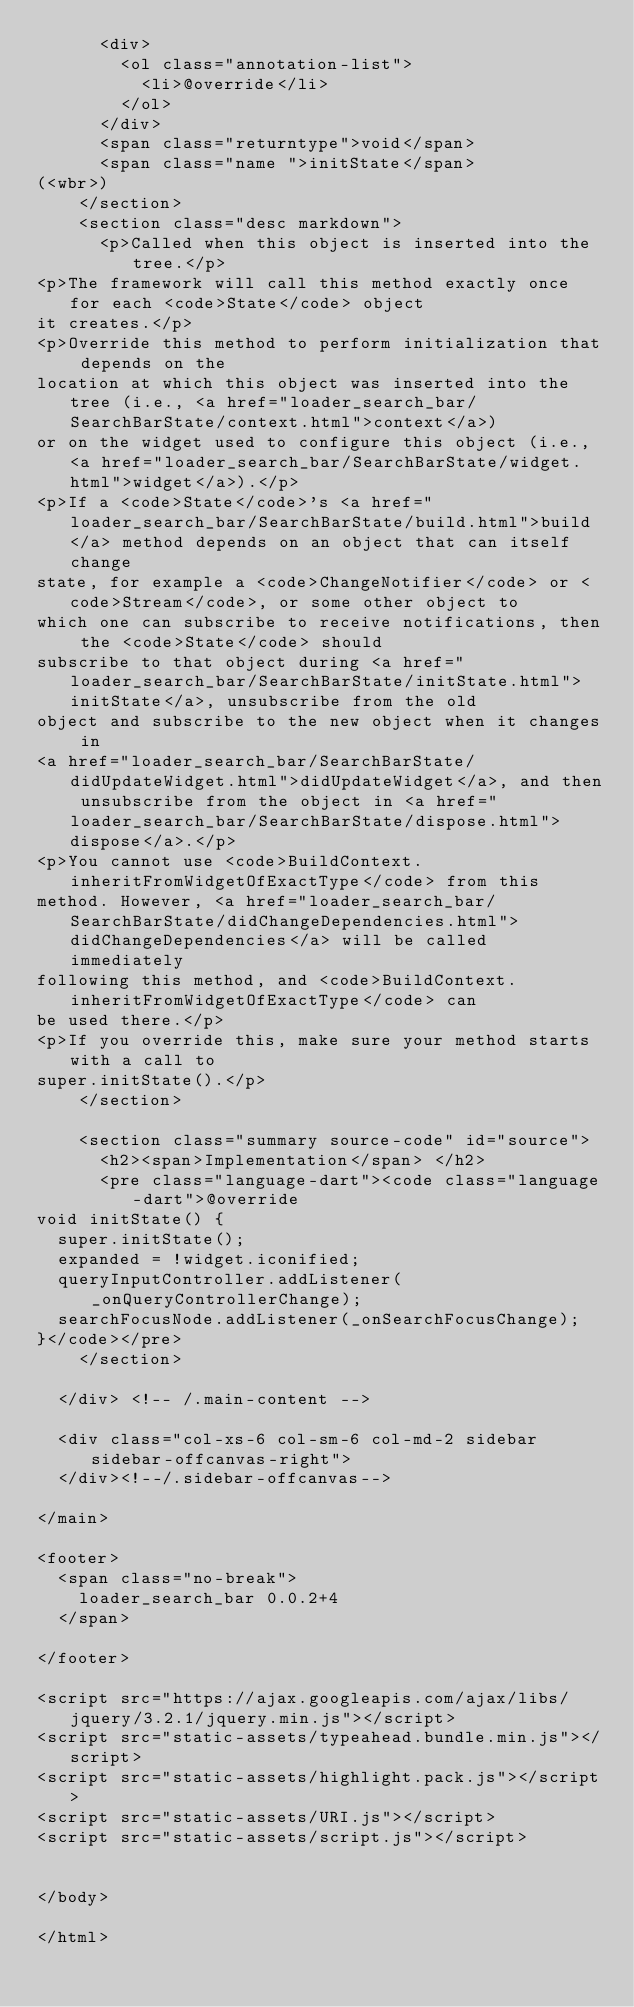<code> <loc_0><loc_0><loc_500><loc_500><_HTML_>      <div>
        <ol class="annotation-list">
          <li>@override</li>
        </ol>
      </div>
      <span class="returntype">void</span>
      <span class="name ">initState</span>
(<wbr>)
    </section>
    <section class="desc markdown">
      <p>Called when this object is inserted into the tree.</p>
<p>The framework will call this method exactly once for each <code>State</code> object
it creates.</p>
<p>Override this method to perform initialization that depends on the
location at which this object was inserted into the tree (i.e., <a href="loader_search_bar/SearchBarState/context.html">context</a>)
or on the widget used to configure this object (i.e., <a href="loader_search_bar/SearchBarState/widget.html">widget</a>).</p>
<p>If a <code>State</code>'s <a href="loader_search_bar/SearchBarState/build.html">build</a> method depends on an object that can itself change
state, for example a <code>ChangeNotifier</code> or <code>Stream</code>, or some other object to
which one can subscribe to receive notifications, then the <code>State</code> should
subscribe to that object during <a href="loader_search_bar/SearchBarState/initState.html">initState</a>, unsubscribe from the old
object and subscribe to the new object when it changes in
<a href="loader_search_bar/SearchBarState/didUpdateWidget.html">didUpdateWidget</a>, and then unsubscribe from the object in <a href="loader_search_bar/SearchBarState/dispose.html">dispose</a>.</p>
<p>You cannot use <code>BuildContext.inheritFromWidgetOfExactType</code> from this
method. However, <a href="loader_search_bar/SearchBarState/didChangeDependencies.html">didChangeDependencies</a> will be called immediately
following this method, and <code>BuildContext.inheritFromWidgetOfExactType</code> can
be used there.</p>
<p>If you override this, make sure your method starts with a call to
super.initState().</p>
    </section>
    
    <section class="summary source-code" id="source">
      <h2><span>Implementation</span> </h2>
      <pre class="language-dart"><code class="language-dart">@override
void initState() {
  super.initState();
  expanded = !widget.iconified;
  queryInputController.addListener(_onQueryControllerChange);
  searchFocusNode.addListener(_onSearchFocusChange);
}</code></pre>
    </section>

  </div> <!-- /.main-content -->

  <div class="col-xs-6 col-sm-6 col-md-2 sidebar sidebar-offcanvas-right">
  </div><!--/.sidebar-offcanvas-->

</main>

<footer>
  <span class="no-break">
    loader_search_bar 0.0.2+4
  </span>

</footer>

<script src="https://ajax.googleapis.com/ajax/libs/jquery/3.2.1/jquery.min.js"></script>
<script src="static-assets/typeahead.bundle.min.js"></script>
<script src="static-assets/highlight.pack.js"></script>
<script src="static-assets/URI.js"></script>
<script src="static-assets/script.js"></script>


</body>

</html>
</code> 